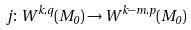Convert formula to latex. <formula><loc_0><loc_0><loc_500><loc_500>j \colon W ^ { k , q } ( M _ { 0 } ) \to W ^ { k - m , p } ( M _ { 0 } )</formula> 